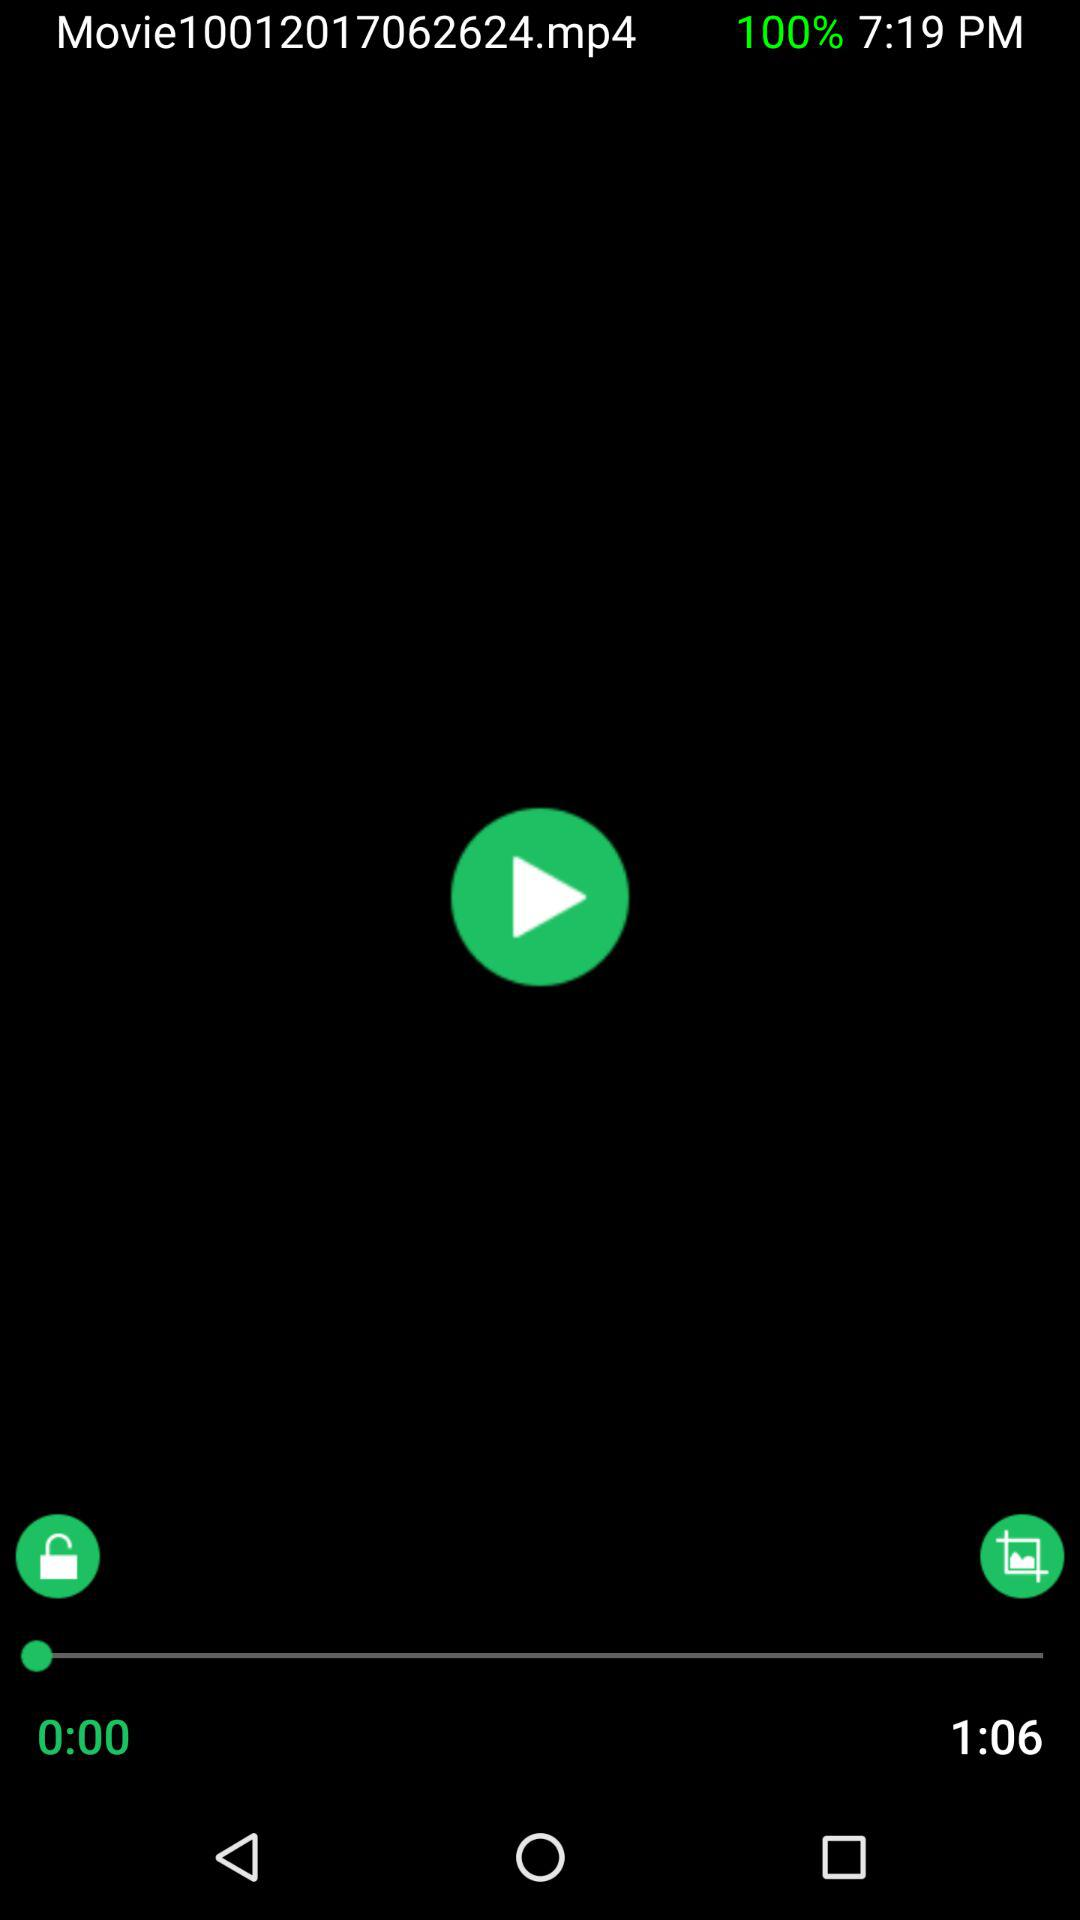What is the length of "Movie1001201"? "Movie1001201" is 1:06 long. 